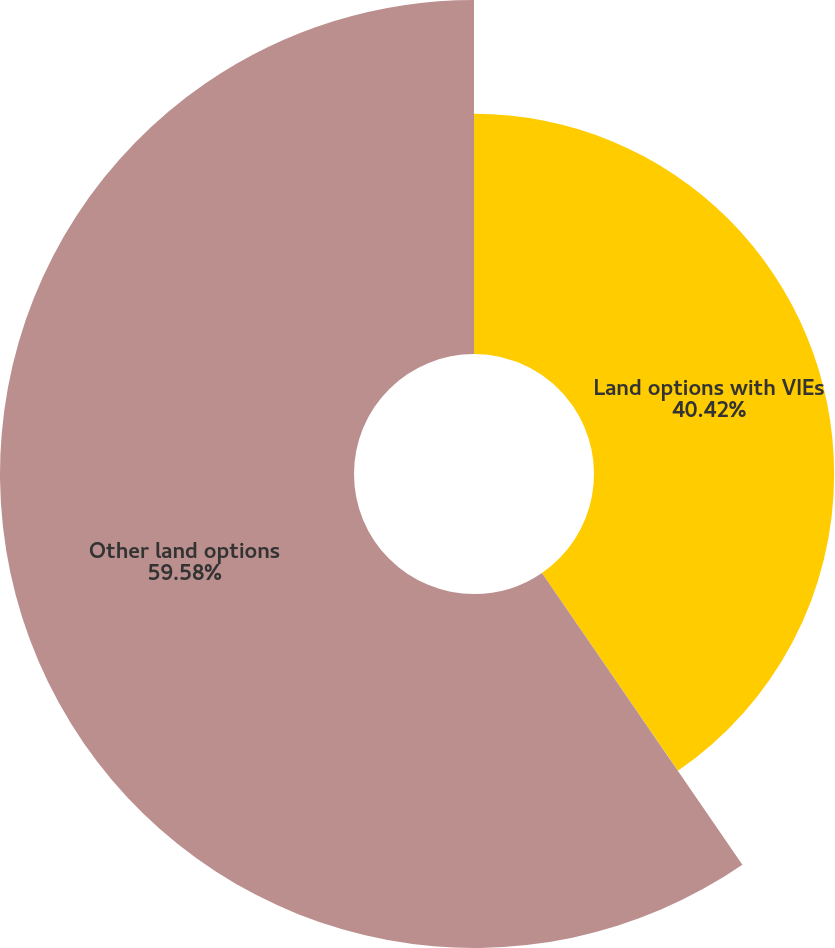Convert chart to OTSL. <chart><loc_0><loc_0><loc_500><loc_500><pie_chart><fcel>Land options with VIEs<fcel>Other land options<nl><fcel>40.42%<fcel>59.58%<nl></chart> 